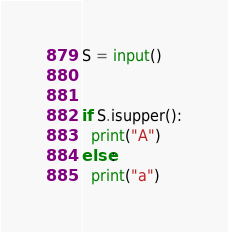Convert code to text. <code><loc_0><loc_0><loc_500><loc_500><_Python_>S = input()


if S.isupper():
  print("A")
else:
  print("a")</code> 